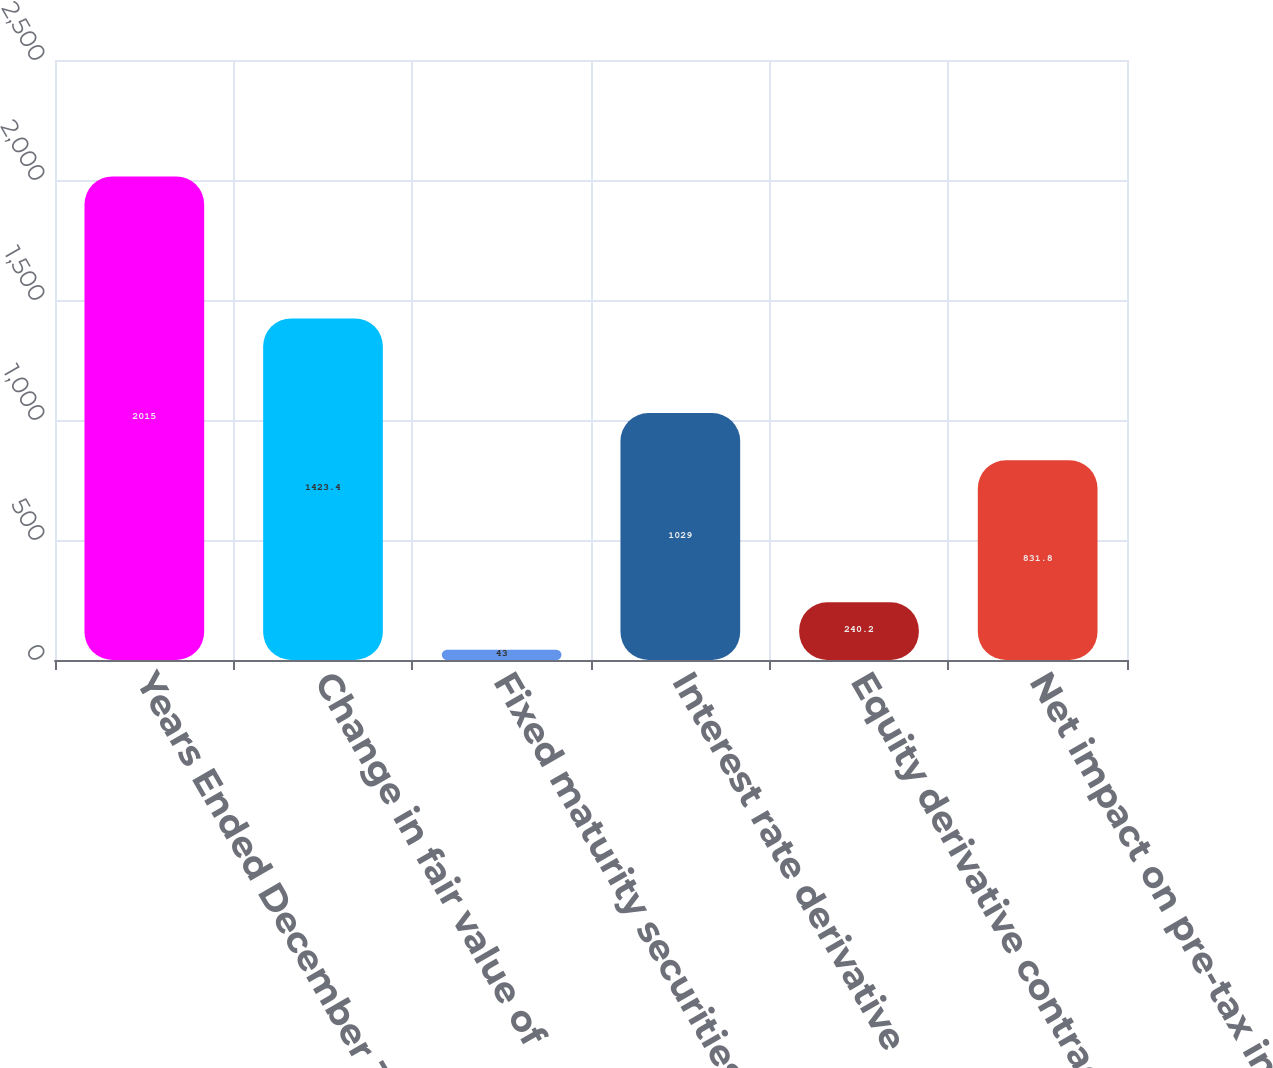<chart> <loc_0><loc_0><loc_500><loc_500><bar_chart><fcel>Years Ended December 31 (in<fcel>Change in fair value of<fcel>Fixed maturity securities<fcel>Interest rate derivative<fcel>Equity derivative contracts<fcel>Net impact on pre-tax income<nl><fcel>2015<fcel>1423.4<fcel>43<fcel>1029<fcel>240.2<fcel>831.8<nl></chart> 